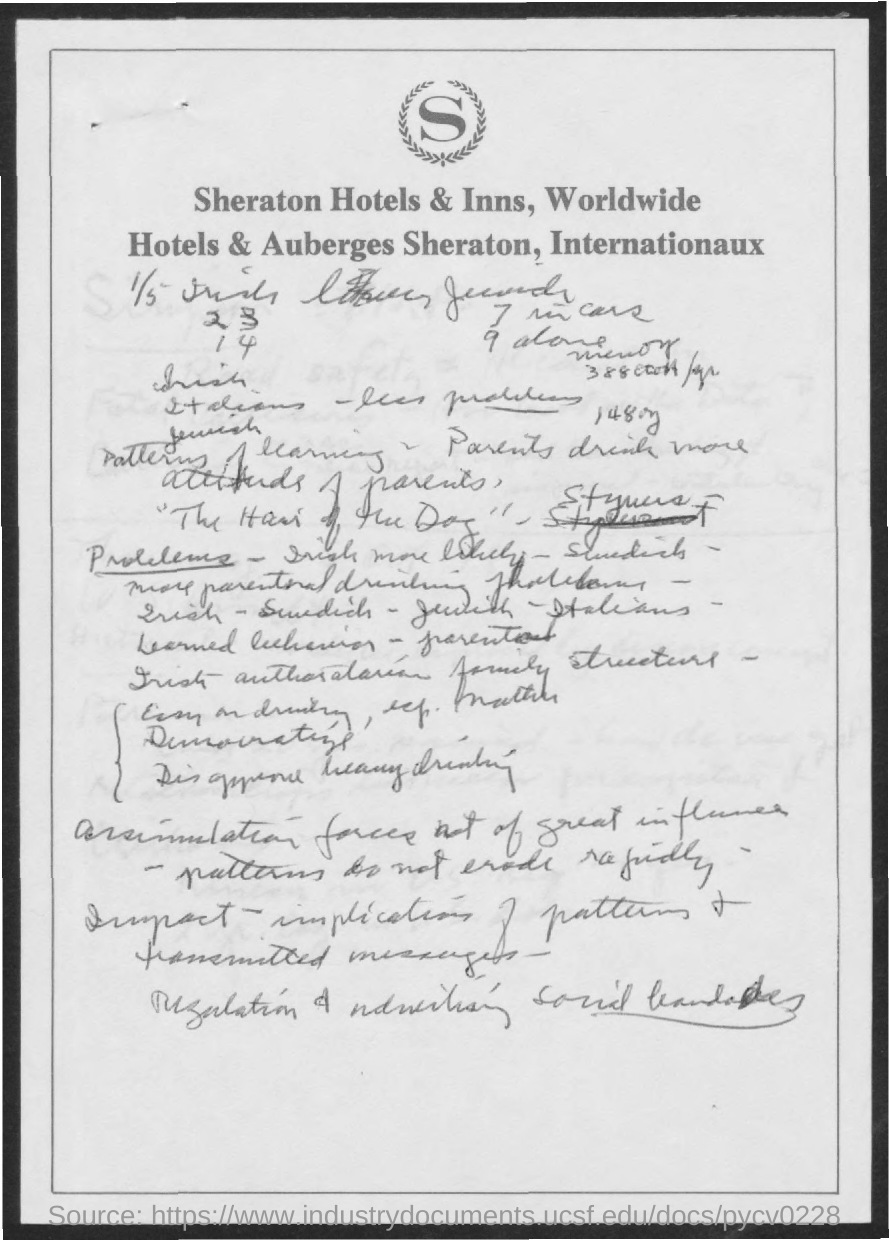Which chain of hotels' letterhead is this?
Provide a short and direct response. Sheraton. 